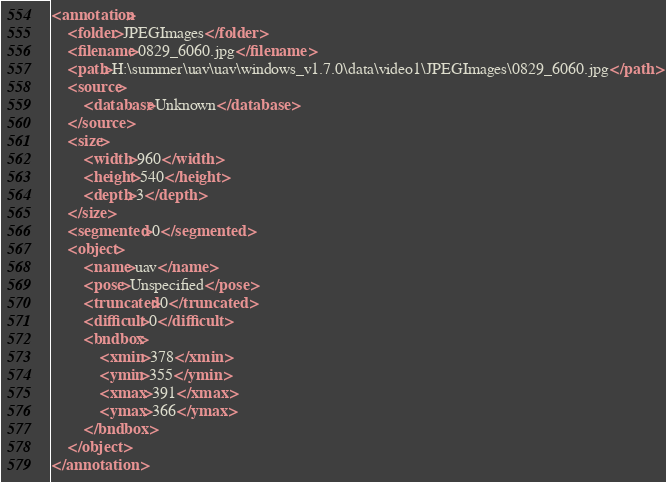Convert code to text. <code><loc_0><loc_0><loc_500><loc_500><_XML_><annotation>
	<folder>JPEGImages</folder>
	<filename>0829_6060.jpg</filename>
	<path>H:\summer\uav\uav\windows_v1.7.0\data\video1\JPEGImages\0829_6060.jpg</path>
	<source>
		<database>Unknown</database>
	</source>
	<size>
		<width>960</width>
		<height>540</height>
		<depth>3</depth>
	</size>
	<segmented>0</segmented>
	<object>
		<name>uav</name>
		<pose>Unspecified</pose>
		<truncated>0</truncated>
		<difficult>0</difficult>
		<bndbox>
			<xmin>378</xmin>
			<ymin>355</ymin>
			<xmax>391</xmax>
			<ymax>366</ymax>
		</bndbox>
	</object>
</annotation>
</code> 